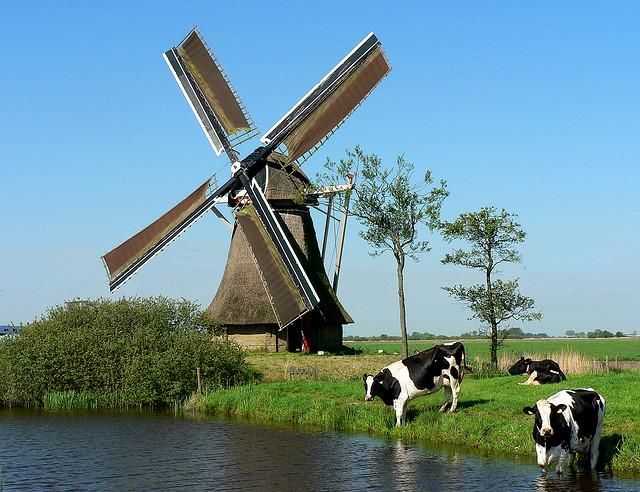What does the building do? Please explain your reasoning. spin. It can generate power or grind grain to make flour. 